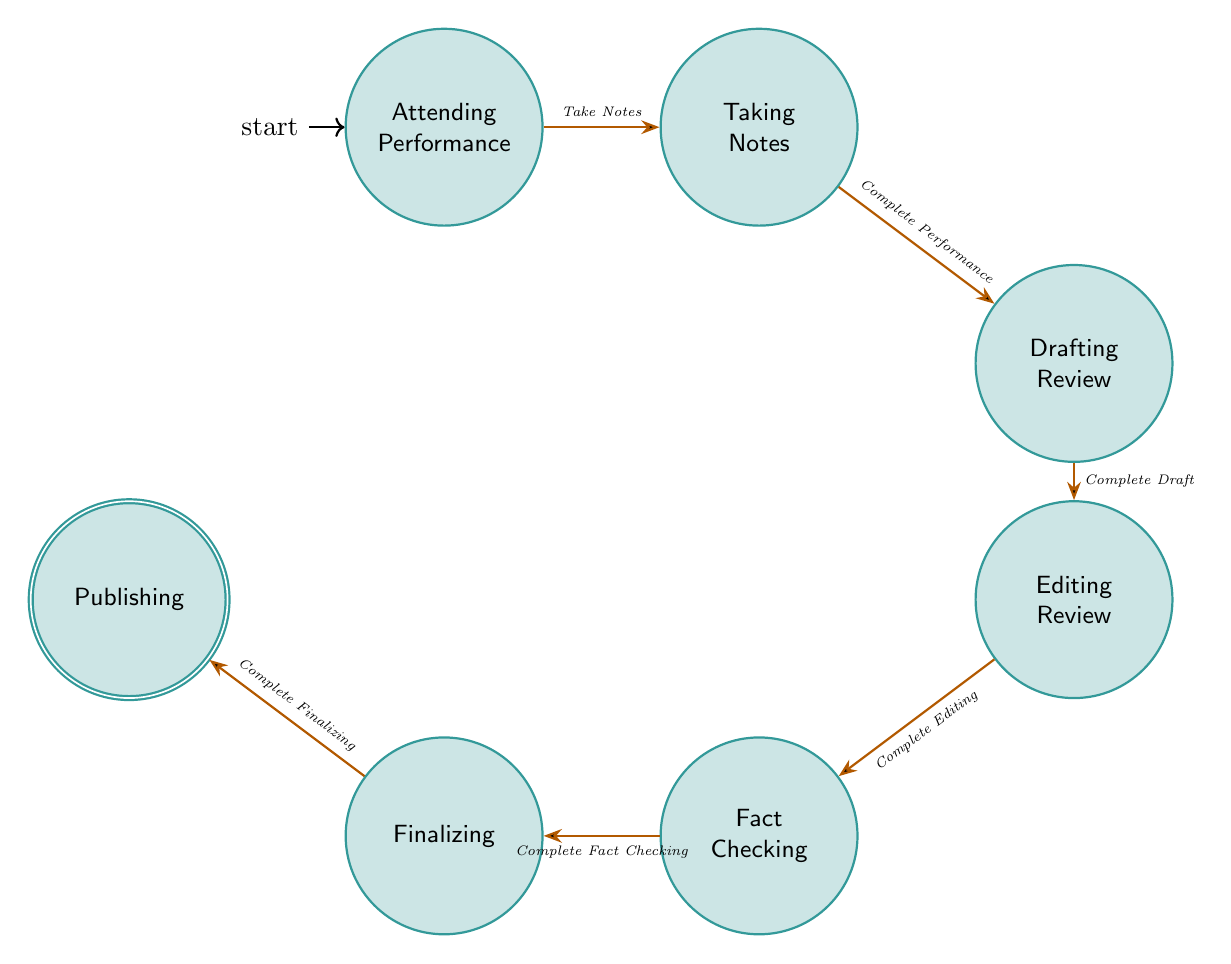What is the initial state of the diagram? The initial state of the diagram is indicated by the arrow pointing towards it, which is the "Attending_Performance" state.
Answer: Attending_Performance How many total states are in the diagram? The diagram shows seven distinct states: Attending_Performance, Taking_Notes, Drafting_Review, Editing_Review, Fact_Checking, Finalizing, and Publishing.
Answer: 7 What action leads from "Taking_Notes" to "Drafting_Review"? The action that transitions from "Taking_Notes" to "Drafting_Review" is marked as "Complete Performance."
Answer: Complete Performance Which state comes before "Fact_Checking"? The state that directly precedes "Fact_Checking" in the diagram is "Editing_Review," indicating the last step before verifying facts.
Answer: Editing_Review What is the last state before publishing the review? The state just before "Publishing" in the flow of the diagram is "Finalizing," where the review is formatted and prepared for publication.
Answer: Finalizing How many transitions are present in the diagram? Counting the connections between states, there are six transitions: from Attending_Performance to Taking_Notes, and so forth until reaching Publishing.
Answer: 6 Which action is performed after "Editing_Review"? The action performed following "Editing_Review" is "Complete Editing," which leads into the "Fact_Checking" state, signifying the completion of the editing process.
Answer: Complete Editing In which state does the review undergo its initial writing? The review's initial writing occurs in the "Drafting_Review" state, following the completion of note-taking during the performance.
Answer: Drafting_Review Which state indicates the completion and preparation for publication? The "Finalizing" state is the step focused on the formatting and final preparations required before the review can be published.
Answer: Finalizing 